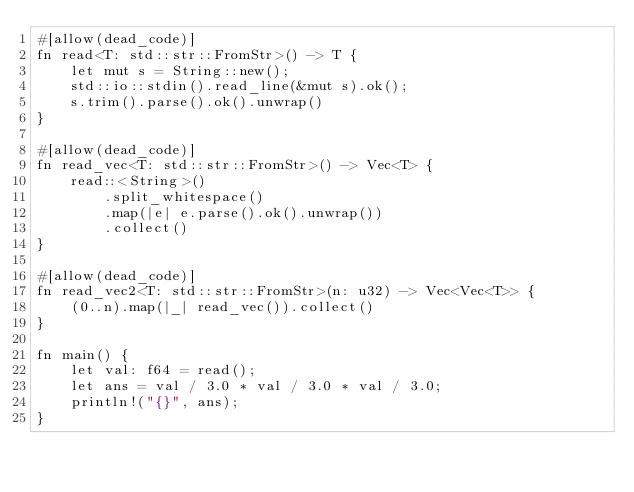<code> <loc_0><loc_0><loc_500><loc_500><_Rust_>#[allow(dead_code)]
fn read<T: std::str::FromStr>() -> T {
    let mut s = String::new();
    std::io::stdin().read_line(&mut s).ok();
    s.trim().parse().ok().unwrap()
}

#[allow(dead_code)]
fn read_vec<T: std::str::FromStr>() -> Vec<T> {
    read::<String>()
        .split_whitespace()
        .map(|e| e.parse().ok().unwrap())
        .collect()
}

#[allow(dead_code)]
fn read_vec2<T: std::str::FromStr>(n: u32) -> Vec<Vec<T>> {
    (0..n).map(|_| read_vec()).collect()
}

fn main() {
    let val: f64 = read();
    let ans = val / 3.0 * val / 3.0 * val / 3.0;
    println!("{}", ans);
}
</code> 